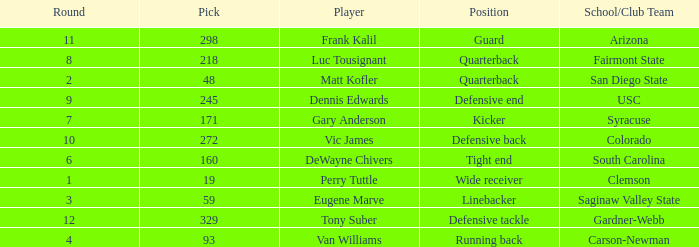Which Round has a School/Club Team of arizona, and a Pick smaller than 298? None. Give me the full table as a dictionary. {'header': ['Round', 'Pick', 'Player', 'Position', 'School/Club Team'], 'rows': [['11', '298', 'Frank Kalil', 'Guard', 'Arizona'], ['8', '218', 'Luc Tousignant', 'Quarterback', 'Fairmont State'], ['2', '48', 'Matt Kofler', 'Quarterback', 'San Diego State'], ['9', '245', 'Dennis Edwards', 'Defensive end', 'USC'], ['7', '171', 'Gary Anderson', 'Kicker', 'Syracuse'], ['10', '272', 'Vic James', 'Defensive back', 'Colorado'], ['6', '160', 'DeWayne Chivers', 'Tight end', 'South Carolina'], ['1', '19', 'Perry Tuttle', 'Wide receiver', 'Clemson'], ['3', '59', 'Eugene Marve', 'Linebacker', 'Saginaw Valley State'], ['12', '329', 'Tony Suber', 'Defensive tackle', 'Gardner-Webb'], ['4', '93', 'Van Williams', 'Running back', 'Carson-Newman']]} 